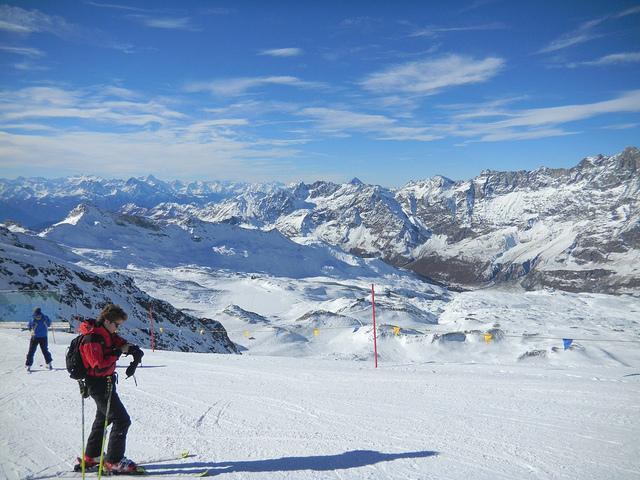Where is the sun with respect to the person wearing red coat?
Indicate the correct response by choosing from the four available options to answer the question.
Options: Front, right, left, back. Back. 